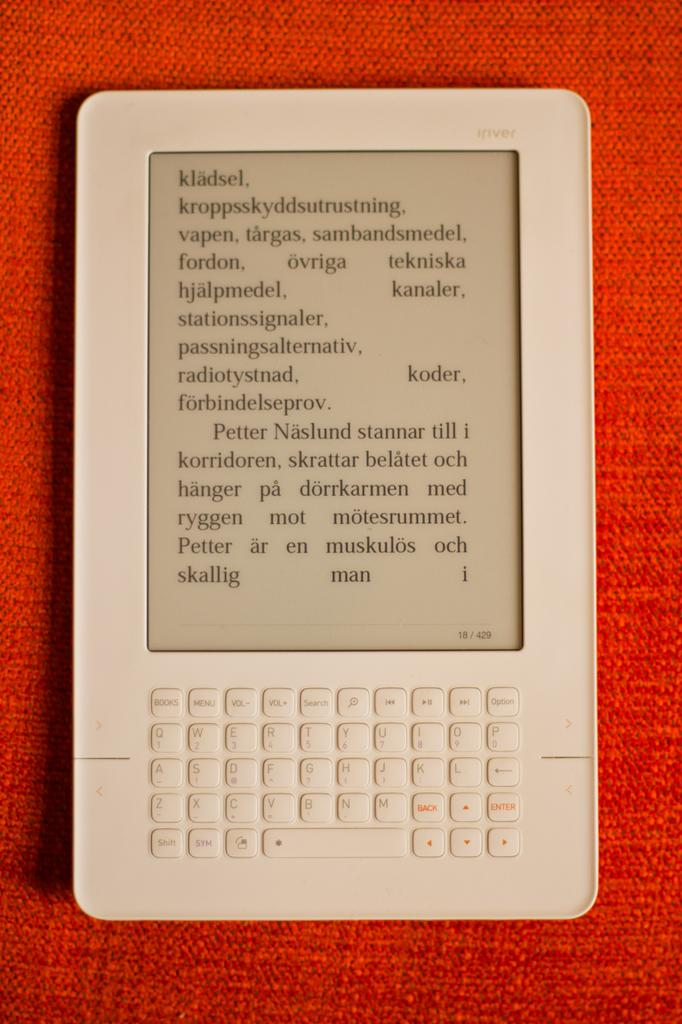<image>
Give a short and clear explanation of the subsequent image. White device with a screen that shows page 18. 